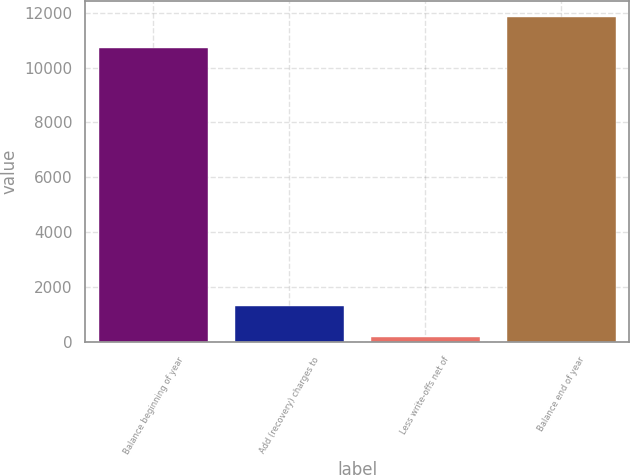Convert chart to OTSL. <chart><loc_0><loc_0><loc_500><loc_500><bar_chart><fcel>Balance beginning of year<fcel>Add (recovery) charges to<fcel>Less write-offs net of<fcel>Balance end of year<nl><fcel>10708<fcel>1326.9<fcel>190<fcel>11844.9<nl></chart> 